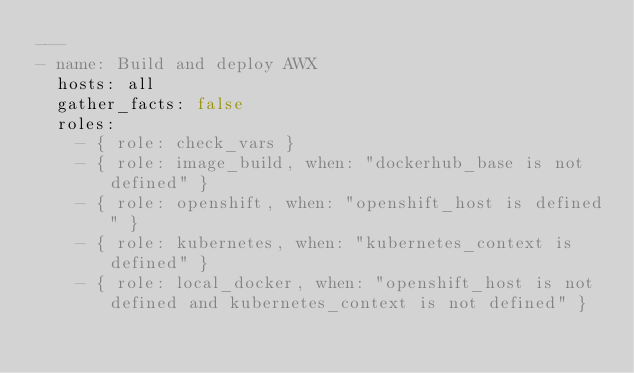Convert code to text. <code><loc_0><loc_0><loc_500><loc_500><_YAML_>---
- name: Build and deploy AWX
  hosts: all
  gather_facts: false
  roles:
    - { role: check_vars }
    - { role: image_build, when: "dockerhub_base is not defined" }
    - { role: openshift, when: "openshift_host is defined" }
    - { role: kubernetes, when: "kubernetes_context is defined" }
    - { role: local_docker, when: "openshift_host is not defined and kubernetes_context is not defined" }
</code> 